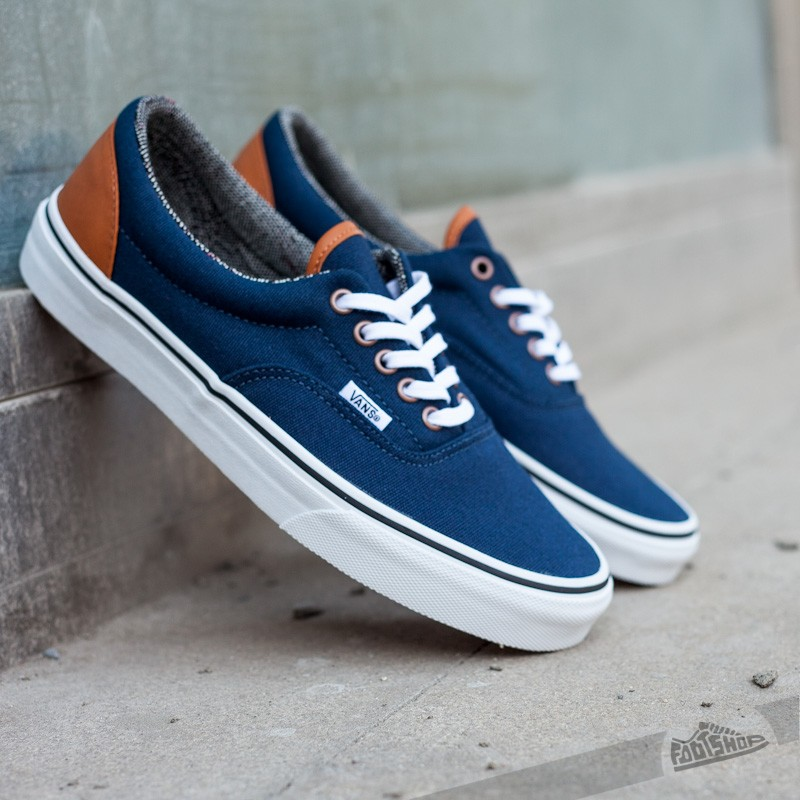Can you provide a brief history of this sneaker brand's evolution? The brand in question has a rich history that dates back to 1966 when it was founded in California. Originally focusing on skateboarding shoes, the brand quickly gained popularity for its durable and fashionable footwear. Over the decades, it has expanded its product line to include a variety of styles while maintaining its strong association with youth culture and the skateboarding community. The brand is now a global icon, known for its classic designs and committed to staying true to its roots. 